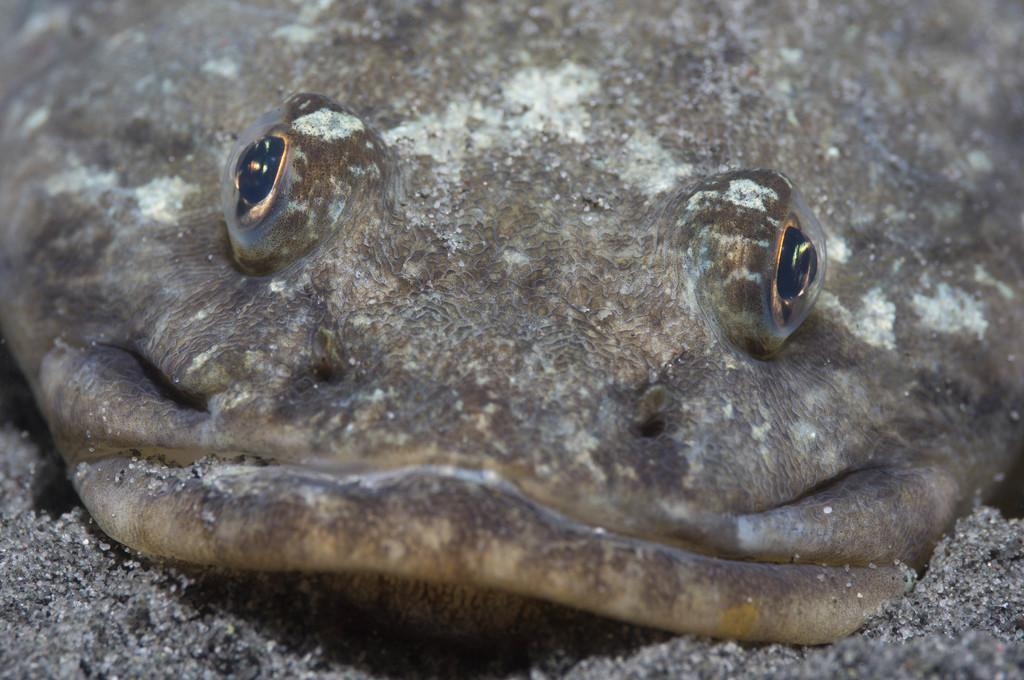What type of animal is present in the image? There is a reptile in the image. Can you describe the color of the reptile? The reptile is brown in color. What type of fabric is the reptile using to wrap itself in the image? There is no fabric or wrapping present in the image; the reptile is simply brown in color. 